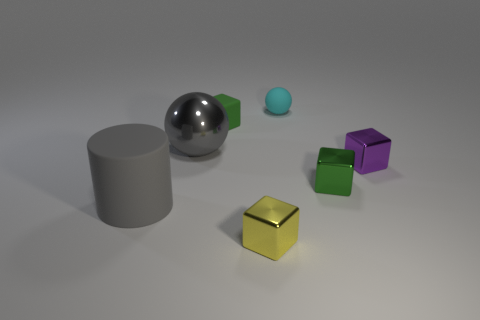How many green things are either matte balls or tiny rubber cubes?
Offer a very short reply. 1. There is a thing in front of the thing that is on the left side of the big metal object; how big is it?
Make the answer very short. Small. There is a yellow object that is the same shape as the purple object; what material is it?
Your answer should be very brief. Metal. What number of cyan things have the same size as the gray ball?
Your response must be concise. 0. Do the purple block and the rubber sphere have the same size?
Offer a very short reply. Yes. There is a object that is both in front of the purple object and to the right of the cyan sphere; what is its size?
Keep it short and to the point. Small. Are there more rubber cylinders that are on the right side of the small cyan sphere than small yellow objects that are left of the rubber cylinder?
Your response must be concise. No. There is a matte object that is the same shape as the purple shiny thing; what is its color?
Offer a terse response. Green. There is a matte thing that is behind the green matte object; is it the same color as the cylinder?
Your answer should be compact. No. What number of brown cylinders are there?
Make the answer very short. 0. 